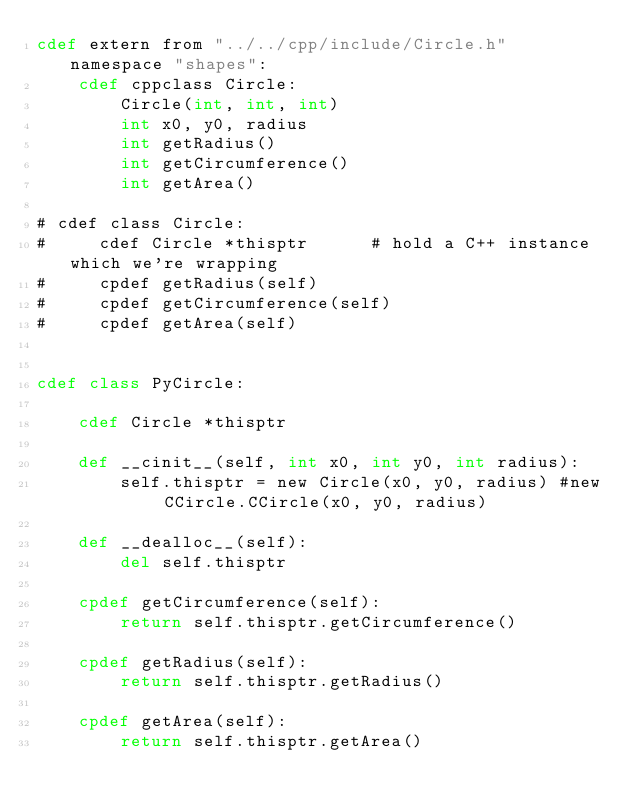<code> <loc_0><loc_0><loc_500><loc_500><_Cython_>cdef extern from "../../cpp/include/Circle.h" namespace "shapes":
    cdef cppclass Circle:
        Circle(int, int, int)
        int x0, y0, radius
        int getRadius()
        int getCircumference()
        int getArea()

# cdef class Circle:
#     cdef Circle *thisptr      # hold a C++ instance which we're wrapping
#     cpdef getRadius(self)
#     cpdef getCircumference(self)
#     cpdef getArea(self)


cdef class PyCircle:

    cdef Circle *thisptr

    def __cinit__(self, int x0, int y0, int radius):
        self.thisptr = new Circle(x0, y0, radius) #new CCircle.CCircle(x0, y0, radius)

    def __dealloc__(self):
        del self.thisptr

    cpdef getCircumference(self):
        return self.thisptr.getCircumference()

    cpdef getRadius(self):
        return self.thisptr.getRadius()

    cpdef getArea(self):
        return self.thisptr.getArea()
</code> 